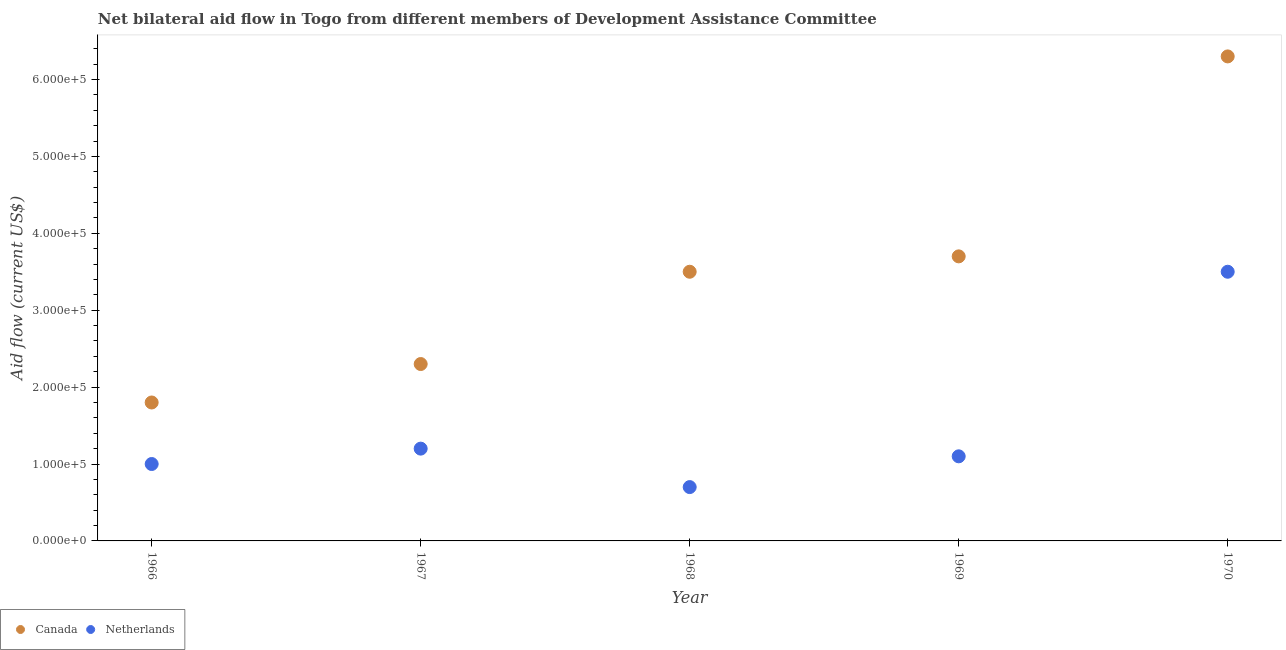How many different coloured dotlines are there?
Provide a succinct answer. 2. Is the number of dotlines equal to the number of legend labels?
Give a very brief answer. Yes. What is the amount of aid given by netherlands in 1969?
Make the answer very short. 1.10e+05. Across all years, what is the maximum amount of aid given by netherlands?
Make the answer very short. 3.50e+05. Across all years, what is the minimum amount of aid given by netherlands?
Keep it short and to the point. 7.00e+04. In which year was the amount of aid given by canada minimum?
Offer a terse response. 1966. What is the total amount of aid given by canada in the graph?
Give a very brief answer. 1.76e+06. What is the difference between the amount of aid given by canada in 1969 and that in 1970?
Your response must be concise. -2.60e+05. What is the difference between the amount of aid given by netherlands in 1966 and the amount of aid given by canada in 1970?
Ensure brevity in your answer.  -5.30e+05. In the year 1966, what is the difference between the amount of aid given by canada and amount of aid given by netherlands?
Your response must be concise. 8.00e+04. What is the ratio of the amount of aid given by netherlands in 1968 to that in 1970?
Offer a very short reply. 0.2. Is the amount of aid given by canada in 1966 less than that in 1968?
Keep it short and to the point. Yes. What is the difference between the highest and the second highest amount of aid given by netherlands?
Your answer should be very brief. 2.30e+05. What is the difference between the highest and the lowest amount of aid given by canada?
Provide a succinct answer. 4.50e+05. Is the sum of the amount of aid given by netherlands in 1966 and 1967 greater than the maximum amount of aid given by canada across all years?
Offer a terse response. No. Are the values on the major ticks of Y-axis written in scientific E-notation?
Ensure brevity in your answer.  Yes. Does the graph contain grids?
Provide a short and direct response. No. Where does the legend appear in the graph?
Your response must be concise. Bottom left. How many legend labels are there?
Provide a succinct answer. 2. How are the legend labels stacked?
Provide a succinct answer. Horizontal. What is the title of the graph?
Keep it short and to the point. Net bilateral aid flow in Togo from different members of Development Assistance Committee. Does "Central government" appear as one of the legend labels in the graph?
Your answer should be very brief. No. What is the label or title of the Y-axis?
Offer a terse response. Aid flow (current US$). What is the Aid flow (current US$) in Canada in 1966?
Your answer should be very brief. 1.80e+05. What is the Aid flow (current US$) of Canada in 1968?
Your response must be concise. 3.50e+05. What is the Aid flow (current US$) of Canada in 1969?
Your response must be concise. 3.70e+05. What is the Aid flow (current US$) in Netherlands in 1969?
Your answer should be very brief. 1.10e+05. What is the Aid flow (current US$) of Canada in 1970?
Keep it short and to the point. 6.30e+05. What is the Aid flow (current US$) in Netherlands in 1970?
Your answer should be very brief. 3.50e+05. Across all years, what is the maximum Aid flow (current US$) in Canada?
Provide a succinct answer. 6.30e+05. Across all years, what is the minimum Aid flow (current US$) of Canada?
Your response must be concise. 1.80e+05. Across all years, what is the minimum Aid flow (current US$) of Netherlands?
Offer a very short reply. 7.00e+04. What is the total Aid flow (current US$) of Canada in the graph?
Your answer should be compact. 1.76e+06. What is the total Aid flow (current US$) in Netherlands in the graph?
Keep it short and to the point. 7.50e+05. What is the difference between the Aid flow (current US$) of Canada in 1966 and that in 1967?
Provide a succinct answer. -5.00e+04. What is the difference between the Aid flow (current US$) in Netherlands in 1966 and that in 1968?
Provide a short and direct response. 3.00e+04. What is the difference between the Aid flow (current US$) of Canada in 1966 and that in 1969?
Offer a terse response. -1.90e+05. What is the difference between the Aid flow (current US$) in Netherlands in 1966 and that in 1969?
Your answer should be very brief. -10000. What is the difference between the Aid flow (current US$) of Canada in 1966 and that in 1970?
Give a very brief answer. -4.50e+05. What is the difference between the Aid flow (current US$) in Canada in 1967 and that in 1968?
Make the answer very short. -1.20e+05. What is the difference between the Aid flow (current US$) of Canada in 1967 and that in 1969?
Make the answer very short. -1.40e+05. What is the difference between the Aid flow (current US$) in Canada in 1967 and that in 1970?
Your answer should be very brief. -4.00e+05. What is the difference between the Aid flow (current US$) in Canada in 1968 and that in 1969?
Your answer should be very brief. -2.00e+04. What is the difference between the Aid flow (current US$) in Canada in 1968 and that in 1970?
Your answer should be compact. -2.80e+05. What is the difference between the Aid flow (current US$) in Netherlands in 1968 and that in 1970?
Give a very brief answer. -2.80e+05. What is the difference between the Aid flow (current US$) of Canada in 1969 and that in 1970?
Your answer should be compact. -2.60e+05. What is the difference between the Aid flow (current US$) in Netherlands in 1969 and that in 1970?
Provide a succinct answer. -2.40e+05. What is the difference between the Aid flow (current US$) of Canada in 1966 and the Aid flow (current US$) of Netherlands in 1967?
Your answer should be compact. 6.00e+04. What is the difference between the Aid flow (current US$) of Canada in 1966 and the Aid flow (current US$) of Netherlands in 1970?
Offer a terse response. -1.70e+05. What is the difference between the Aid flow (current US$) of Canada in 1967 and the Aid flow (current US$) of Netherlands in 1969?
Provide a succinct answer. 1.20e+05. What is the difference between the Aid flow (current US$) of Canada in 1967 and the Aid flow (current US$) of Netherlands in 1970?
Give a very brief answer. -1.20e+05. What is the average Aid flow (current US$) of Canada per year?
Keep it short and to the point. 3.52e+05. In the year 1966, what is the difference between the Aid flow (current US$) of Canada and Aid flow (current US$) of Netherlands?
Make the answer very short. 8.00e+04. In the year 1968, what is the difference between the Aid flow (current US$) in Canada and Aid flow (current US$) in Netherlands?
Give a very brief answer. 2.80e+05. What is the ratio of the Aid flow (current US$) of Canada in 1966 to that in 1967?
Make the answer very short. 0.78. What is the ratio of the Aid flow (current US$) in Netherlands in 1966 to that in 1967?
Give a very brief answer. 0.83. What is the ratio of the Aid flow (current US$) in Canada in 1966 to that in 1968?
Provide a succinct answer. 0.51. What is the ratio of the Aid flow (current US$) in Netherlands in 1966 to that in 1968?
Offer a terse response. 1.43. What is the ratio of the Aid flow (current US$) of Canada in 1966 to that in 1969?
Give a very brief answer. 0.49. What is the ratio of the Aid flow (current US$) of Netherlands in 1966 to that in 1969?
Provide a succinct answer. 0.91. What is the ratio of the Aid flow (current US$) in Canada in 1966 to that in 1970?
Your answer should be compact. 0.29. What is the ratio of the Aid flow (current US$) in Netherlands in 1966 to that in 1970?
Give a very brief answer. 0.29. What is the ratio of the Aid flow (current US$) in Canada in 1967 to that in 1968?
Give a very brief answer. 0.66. What is the ratio of the Aid flow (current US$) in Netherlands in 1967 to that in 1968?
Give a very brief answer. 1.71. What is the ratio of the Aid flow (current US$) in Canada in 1967 to that in 1969?
Your answer should be compact. 0.62. What is the ratio of the Aid flow (current US$) of Netherlands in 1967 to that in 1969?
Provide a short and direct response. 1.09. What is the ratio of the Aid flow (current US$) of Canada in 1967 to that in 1970?
Provide a succinct answer. 0.37. What is the ratio of the Aid flow (current US$) of Netherlands in 1967 to that in 1970?
Your answer should be compact. 0.34. What is the ratio of the Aid flow (current US$) in Canada in 1968 to that in 1969?
Offer a very short reply. 0.95. What is the ratio of the Aid flow (current US$) in Netherlands in 1968 to that in 1969?
Your response must be concise. 0.64. What is the ratio of the Aid flow (current US$) of Canada in 1968 to that in 1970?
Give a very brief answer. 0.56. What is the ratio of the Aid flow (current US$) of Netherlands in 1968 to that in 1970?
Give a very brief answer. 0.2. What is the ratio of the Aid flow (current US$) in Canada in 1969 to that in 1970?
Offer a terse response. 0.59. What is the ratio of the Aid flow (current US$) in Netherlands in 1969 to that in 1970?
Keep it short and to the point. 0.31. What is the difference between the highest and the second highest Aid flow (current US$) of Canada?
Offer a terse response. 2.60e+05. What is the difference between the highest and the lowest Aid flow (current US$) of Canada?
Provide a succinct answer. 4.50e+05. 